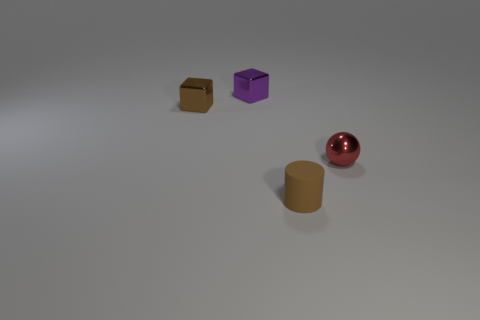Add 3 large blue rubber cubes. How many objects exist? 7 Subtract all balls. How many objects are left? 3 Subtract 0 yellow balls. How many objects are left? 4 Subtract all small objects. Subtract all tiny gray rubber spheres. How many objects are left? 0 Add 2 cylinders. How many cylinders are left? 3 Add 4 yellow metal spheres. How many yellow metal spheres exist? 4 